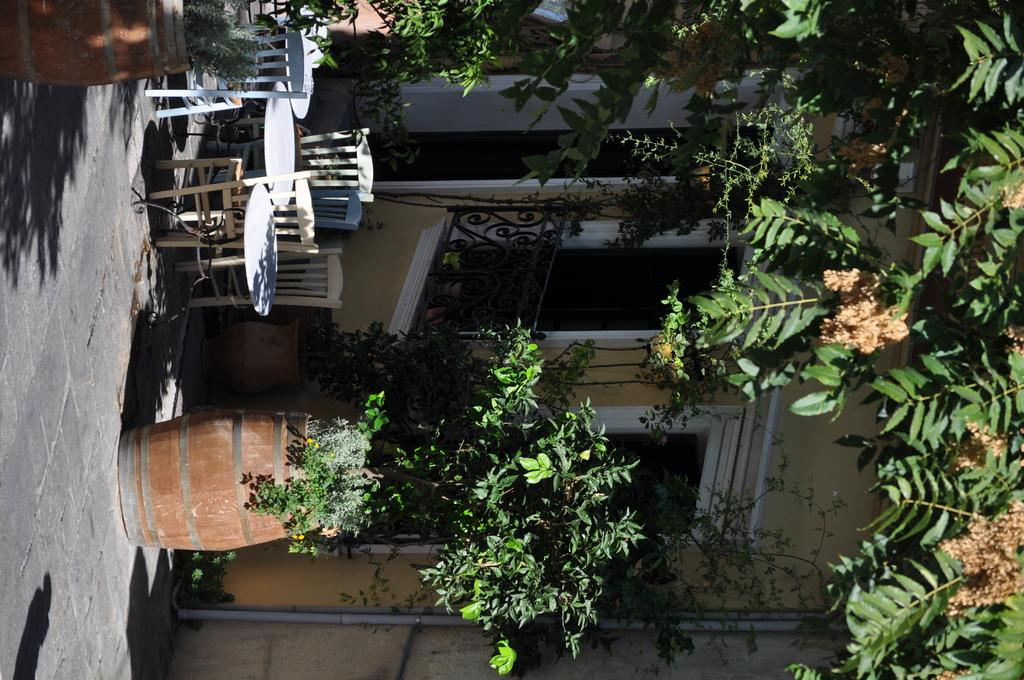How is the image oriented? The image is tilted. What can be seen on the left side of the image? There is a floor, a table, chairs, and flower pots on the left side of the image. What is visible in the background of the image? There is a house and trees in the background of the image. What type of jam is being spread on the snail in the image? There is no snail or jam present in the image. How many flies can be seen on the table in the image? There are no flies present in the image. 